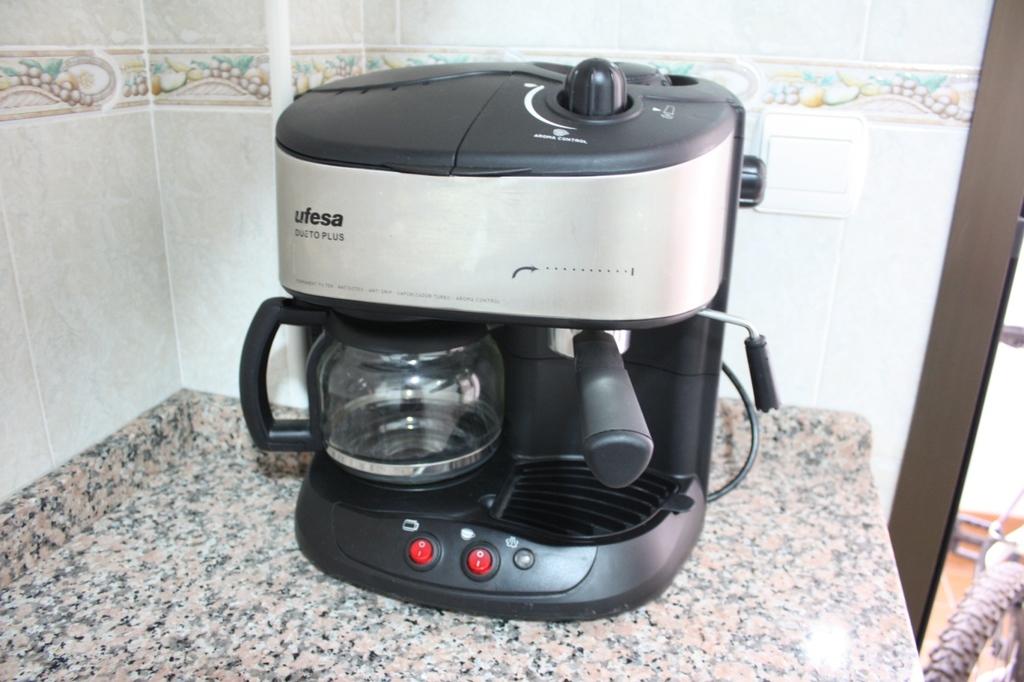What is the model name of this appliance?
Provide a succinct answer. Ufesa. 